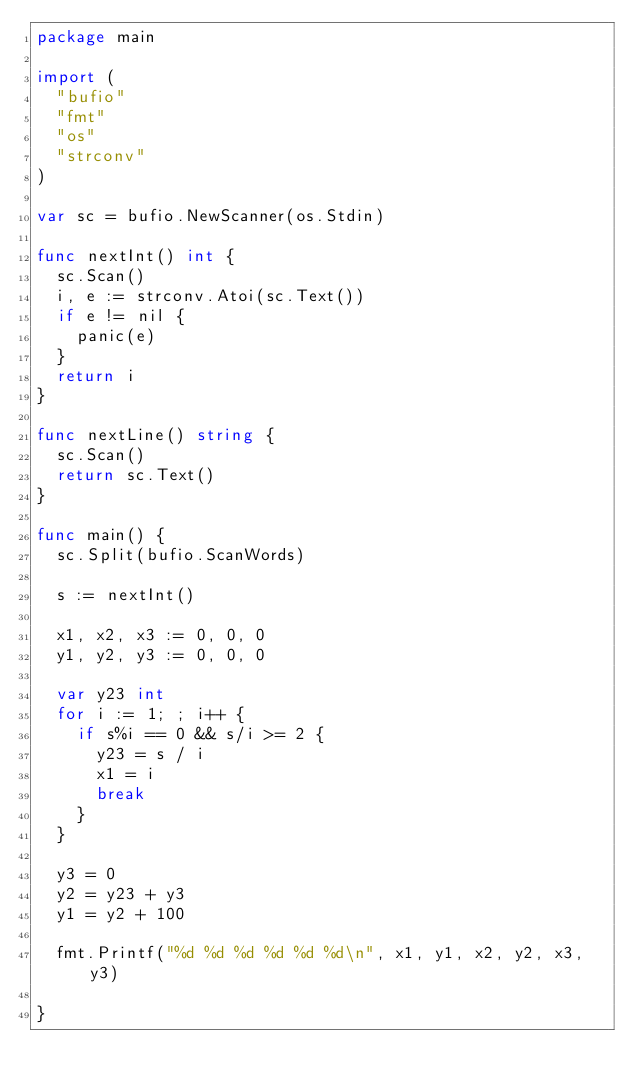Convert code to text. <code><loc_0><loc_0><loc_500><loc_500><_Go_>package main

import (
	"bufio"
	"fmt"
	"os"
	"strconv"
)

var sc = bufio.NewScanner(os.Stdin)

func nextInt() int {
	sc.Scan()
	i, e := strconv.Atoi(sc.Text())
	if e != nil {
		panic(e)
	}
	return i
}

func nextLine() string {
	sc.Scan()
	return sc.Text()
}

func main() {
	sc.Split(bufio.ScanWords)

	s := nextInt()

	x1, x2, x3 := 0, 0, 0
	y1, y2, y3 := 0, 0, 0

	var y23 int
	for i := 1; ; i++ {
		if s%i == 0 && s/i >= 2 {
			y23 = s / i
			x1 = i
			break
		}
	}

	y3 = 0
	y2 = y23 + y3
	y1 = y2 + 100

	fmt.Printf("%d %d %d %d %d %d\n", x1, y1, x2, y2, x3, y3)

}
</code> 